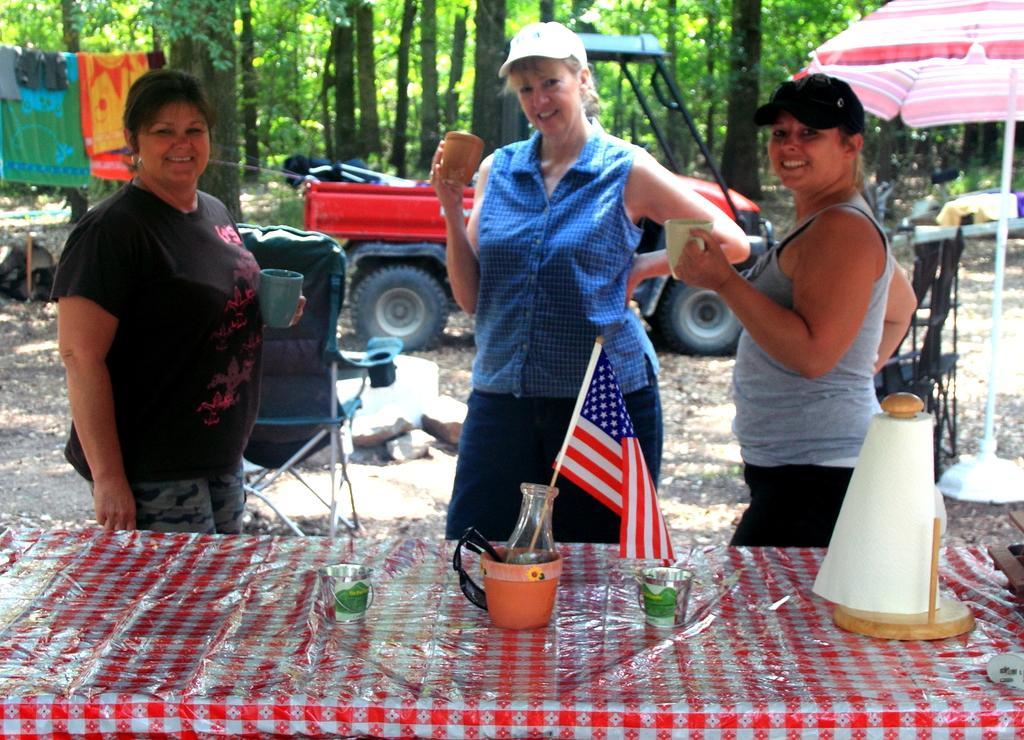How would you summarize this image in a sentence or two? In this image, we can see people standing and holding cups and some are wearing caps. In the background, we can see trees, a vehicle and some clothes which are hanging on the rope and there is an umbrella and there is a chair and we can see a bottle, cups, a flag and some other objects on the tables. At the bottom, there are stones on the ground. 